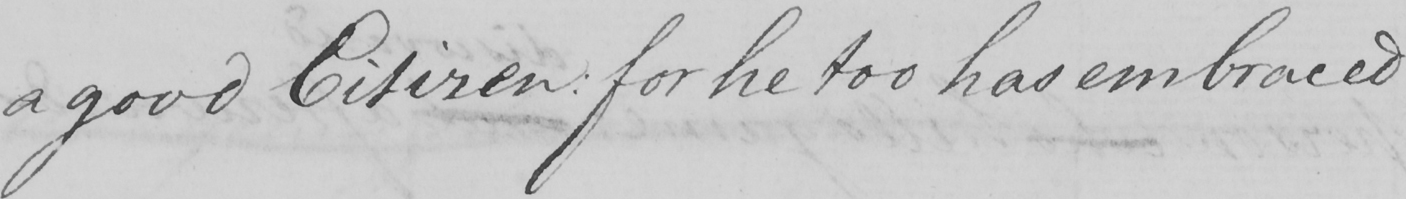Please provide the text content of this handwritten line. a good Citizen :  for he too has embraced 